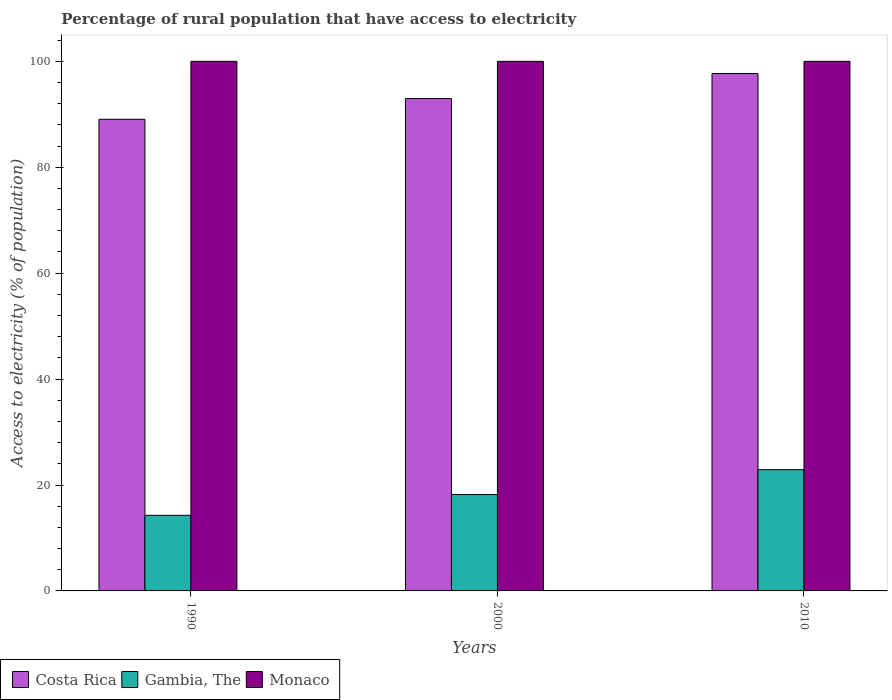How many different coloured bars are there?
Provide a short and direct response. 3. How many groups of bars are there?
Offer a terse response. 3. Are the number of bars per tick equal to the number of legend labels?
Give a very brief answer. Yes. In how many cases, is the number of bars for a given year not equal to the number of legend labels?
Your response must be concise. 0. What is the percentage of rural population that have access to electricity in Gambia, The in 2010?
Make the answer very short. 22.9. Across all years, what is the maximum percentage of rural population that have access to electricity in Monaco?
Give a very brief answer. 100. Across all years, what is the minimum percentage of rural population that have access to electricity in Costa Rica?
Offer a terse response. 89.06. In which year was the percentage of rural population that have access to electricity in Gambia, The maximum?
Ensure brevity in your answer.  2010. What is the total percentage of rural population that have access to electricity in Costa Rica in the graph?
Make the answer very short. 279.74. What is the difference between the percentage of rural population that have access to electricity in Monaco in 1990 and that in 2010?
Provide a succinct answer. 0. What is the difference between the percentage of rural population that have access to electricity in Costa Rica in 2000 and the percentage of rural population that have access to electricity in Monaco in 2010?
Keep it short and to the point. -7.02. What is the average percentage of rural population that have access to electricity in Costa Rica per year?
Your response must be concise. 93.25. In the year 2000, what is the difference between the percentage of rural population that have access to electricity in Monaco and percentage of rural population that have access to electricity in Costa Rica?
Your answer should be compact. 7.02. What is the ratio of the percentage of rural population that have access to electricity in Costa Rica in 1990 to that in 2000?
Give a very brief answer. 0.96. What is the difference between the highest and the lowest percentage of rural population that have access to electricity in Gambia, The?
Offer a very short reply. 8.62. What does the 3rd bar from the left in 2010 represents?
Keep it short and to the point. Monaco. What does the 1st bar from the right in 2000 represents?
Make the answer very short. Monaco. Does the graph contain any zero values?
Make the answer very short. No. How many legend labels are there?
Provide a short and direct response. 3. What is the title of the graph?
Ensure brevity in your answer.  Percentage of rural population that have access to electricity. What is the label or title of the Y-axis?
Your response must be concise. Access to electricity (% of population). What is the Access to electricity (% of population) of Costa Rica in 1990?
Keep it short and to the point. 89.06. What is the Access to electricity (% of population) of Gambia, The in 1990?
Your answer should be compact. 14.28. What is the Access to electricity (% of population) in Costa Rica in 2000?
Provide a succinct answer. 92.98. What is the Access to electricity (% of population) in Monaco in 2000?
Provide a short and direct response. 100. What is the Access to electricity (% of population) of Costa Rica in 2010?
Make the answer very short. 97.7. What is the Access to electricity (% of population) of Gambia, The in 2010?
Ensure brevity in your answer.  22.9. What is the Access to electricity (% of population) of Monaco in 2010?
Give a very brief answer. 100. Across all years, what is the maximum Access to electricity (% of population) in Costa Rica?
Provide a succinct answer. 97.7. Across all years, what is the maximum Access to electricity (% of population) of Gambia, The?
Provide a succinct answer. 22.9. Across all years, what is the maximum Access to electricity (% of population) of Monaco?
Your answer should be compact. 100. Across all years, what is the minimum Access to electricity (% of population) of Costa Rica?
Your answer should be compact. 89.06. Across all years, what is the minimum Access to electricity (% of population) in Gambia, The?
Your answer should be very brief. 14.28. Across all years, what is the minimum Access to electricity (% of population) of Monaco?
Offer a very short reply. 100. What is the total Access to electricity (% of population) in Costa Rica in the graph?
Offer a terse response. 279.74. What is the total Access to electricity (% of population) of Gambia, The in the graph?
Make the answer very short. 55.38. What is the total Access to electricity (% of population) of Monaco in the graph?
Provide a succinct answer. 300. What is the difference between the Access to electricity (% of population) of Costa Rica in 1990 and that in 2000?
Make the answer very short. -3.92. What is the difference between the Access to electricity (% of population) in Gambia, The in 1990 and that in 2000?
Your answer should be compact. -3.92. What is the difference between the Access to electricity (% of population) of Monaco in 1990 and that in 2000?
Provide a short and direct response. 0. What is the difference between the Access to electricity (% of population) in Costa Rica in 1990 and that in 2010?
Keep it short and to the point. -8.64. What is the difference between the Access to electricity (% of population) in Gambia, The in 1990 and that in 2010?
Your answer should be very brief. -8.62. What is the difference between the Access to electricity (% of population) of Monaco in 1990 and that in 2010?
Your response must be concise. 0. What is the difference between the Access to electricity (% of population) of Costa Rica in 2000 and that in 2010?
Your answer should be compact. -4.72. What is the difference between the Access to electricity (% of population) in Monaco in 2000 and that in 2010?
Offer a terse response. 0. What is the difference between the Access to electricity (% of population) in Costa Rica in 1990 and the Access to electricity (% of population) in Gambia, The in 2000?
Offer a terse response. 70.86. What is the difference between the Access to electricity (% of population) in Costa Rica in 1990 and the Access to electricity (% of population) in Monaco in 2000?
Ensure brevity in your answer.  -10.94. What is the difference between the Access to electricity (% of population) in Gambia, The in 1990 and the Access to electricity (% of population) in Monaco in 2000?
Your response must be concise. -85.72. What is the difference between the Access to electricity (% of population) of Costa Rica in 1990 and the Access to electricity (% of population) of Gambia, The in 2010?
Your answer should be compact. 66.16. What is the difference between the Access to electricity (% of population) in Costa Rica in 1990 and the Access to electricity (% of population) in Monaco in 2010?
Give a very brief answer. -10.94. What is the difference between the Access to electricity (% of population) in Gambia, The in 1990 and the Access to electricity (% of population) in Monaco in 2010?
Provide a succinct answer. -85.72. What is the difference between the Access to electricity (% of population) of Costa Rica in 2000 and the Access to electricity (% of population) of Gambia, The in 2010?
Ensure brevity in your answer.  70.08. What is the difference between the Access to electricity (% of population) in Costa Rica in 2000 and the Access to electricity (% of population) in Monaco in 2010?
Keep it short and to the point. -7.02. What is the difference between the Access to electricity (% of population) in Gambia, The in 2000 and the Access to electricity (% of population) in Monaco in 2010?
Provide a succinct answer. -81.8. What is the average Access to electricity (% of population) in Costa Rica per year?
Provide a short and direct response. 93.25. What is the average Access to electricity (% of population) in Gambia, The per year?
Your answer should be compact. 18.46. What is the average Access to electricity (% of population) in Monaco per year?
Offer a terse response. 100. In the year 1990, what is the difference between the Access to electricity (% of population) in Costa Rica and Access to electricity (% of population) in Gambia, The?
Your response must be concise. 74.78. In the year 1990, what is the difference between the Access to electricity (% of population) of Costa Rica and Access to electricity (% of population) of Monaco?
Ensure brevity in your answer.  -10.94. In the year 1990, what is the difference between the Access to electricity (% of population) in Gambia, The and Access to electricity (% of population) in Monaco?
Provide a succinct answer. -85.72. In the year 2000, what is the difference between the Access to electricity (% of population) in Costa Rica and Access to electricity (% of population) in Gambia, The?
Your response must be concise. 74.78. In the year 2000, what is the difference between the Access to electricity (% of population) in Costa Rica and Access to electricity (% of population) in Monaco?
Keep it short and to the point. -7.02. In the year 2000, what is the difference between the Access to electricity (% of population) of Gambia, The and Access to electricity (% of population) of Monaco?
Provide a succinct answer. -81.8. In the year 2010, what is the difference between the Access to electricity (% of population) in Costa Rica and Access to electricity (% of population) in Gambia, The?
Offer a terse response. 74.8. In the year 2010, what is the difference between the Access to electricity (% of population) in Gambia, The and Access to electricity (% of population) in Monaco?
Keep it short and to the point. -77.1. What is the ratio of the Access to electricity (% of population) of Costa Rica in 1990 to that in 2000?
Provide a short and direct response. 0.96. What is the ratio of the Access to electricity (% of population) of Gambia, The in 1990 to that in 2000?
Your answer should be very brief. 0.78. What is the ratio of the Access to electricity (% of population) of Costa Rica in 1990 to that in 2010?
Ensure brevity in your answer.  0.91. What is the ratio of the Access to electricity (% of population) of Gambia, The in 1990 to that in 2010?
Provide a short and direct response. 0.62. What is the ratio of the Access to electricity (% of population) of Monaco in 1990 to that in 2010?
Give a very brief answer. 1. What is the ratio of the Access to electricity (% of population) of Costa Rica in 2000 to that in 2010?
Keep it short and to the point. 0.95. What is the ratio of the Access to electricity (% of population) of Gambia, The in 2000 to that in 2010?
Give a very brief answer. 0.79. What is the ratio of the Access to electricity (% of population) in Monaco in 2000 to that in 2010?
Provide a short and direct response. 1. What is the difference between the highest and the second highest Access to electricity (% of population) of Costa Rica?
Offer a terse response. 4.72. What is the difference between the highest and the second highest Access to electricity (% of population) in Monaco?
Ensure brevity in your answer.  0. What is the difference between the highest and the lowest Access to electricity (% of population) in Costa Rica?
Provide a short and direct response. 8.64. What is the difference between the highest and the lowest Access to electricity (% of population) of Gambia, The?
Provide a short and direct response. 8.62. What is the difference between the highest and the lowest Access to electricity (% of population) of Monaco?
Provide a succinct answer. 0. 